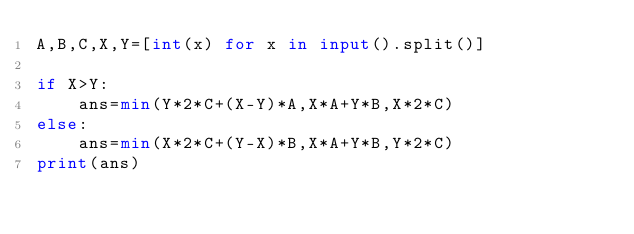Convert code to text. <code><loc_0><loc_0><loc_500><loc_500><_Python_>A,B,C,X,Y=[int(x) for x in input().split()]

if X>Y:
    ans=min(Y*2*C+(X-Y)*A,X*A+Y*B,X*2*C) 
else:
    ans=min(X*2*C+(Y-X)*B,X*A+Y*B,Y*2*C) 
print(ans)</code> 